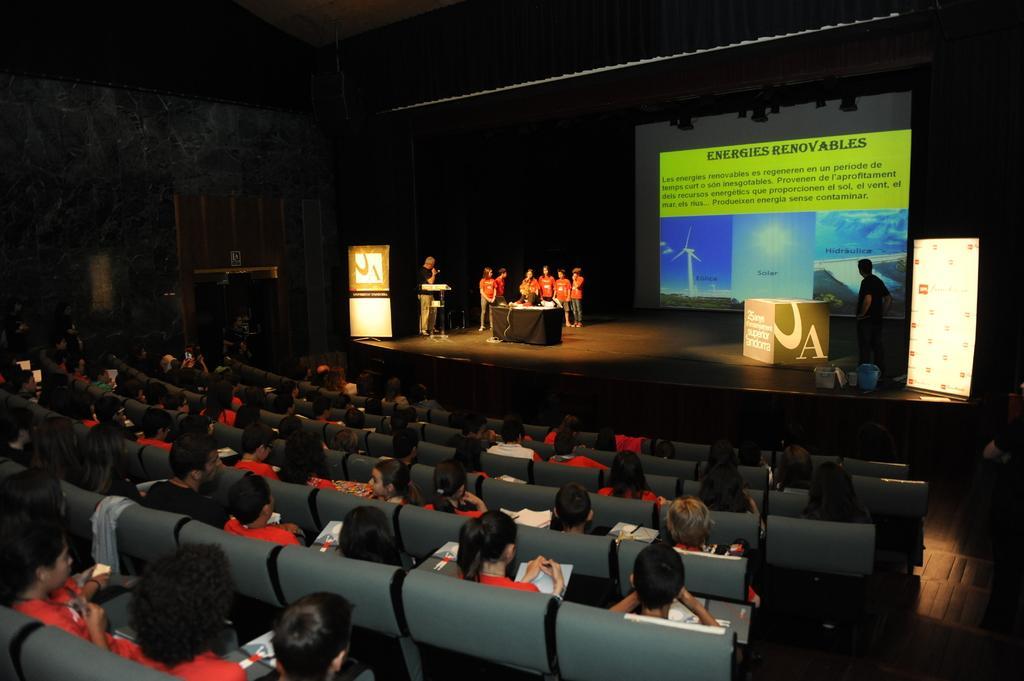How would you summarize this image in a sentence or two? In this picture we can observe some people standing on the stage in front of a table. There are some people sitting in the chairs. There are men and women. In the background we can observe a screen. There is a black color curtain. 